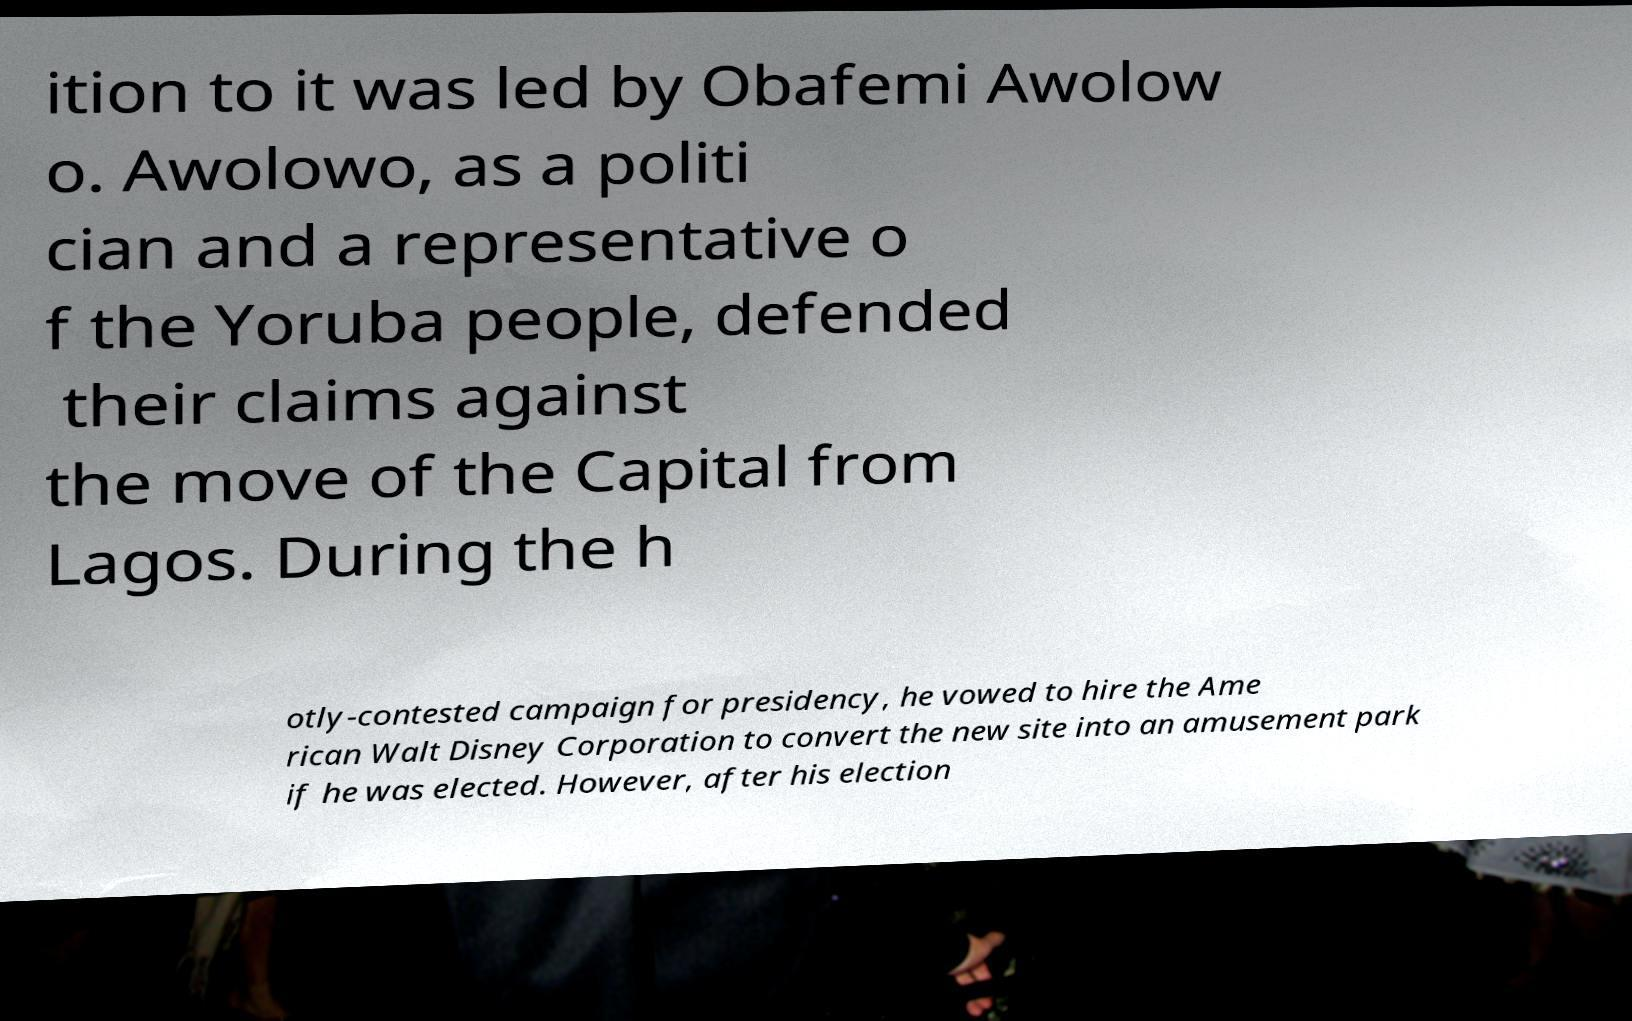Could you extract and type out the text from this image? ition to it was led by Obafemi Awolow o. Awolowo, as a politi cian and a representative o f the Yoruba people, defended their claims against the move of the Capital from Lagos. During the h otly-contested campaign for presidency, he vowed to hire the Ame rican Walt Disney Corporation to convert the new site into an amusement park if he was elected. However, after his election 